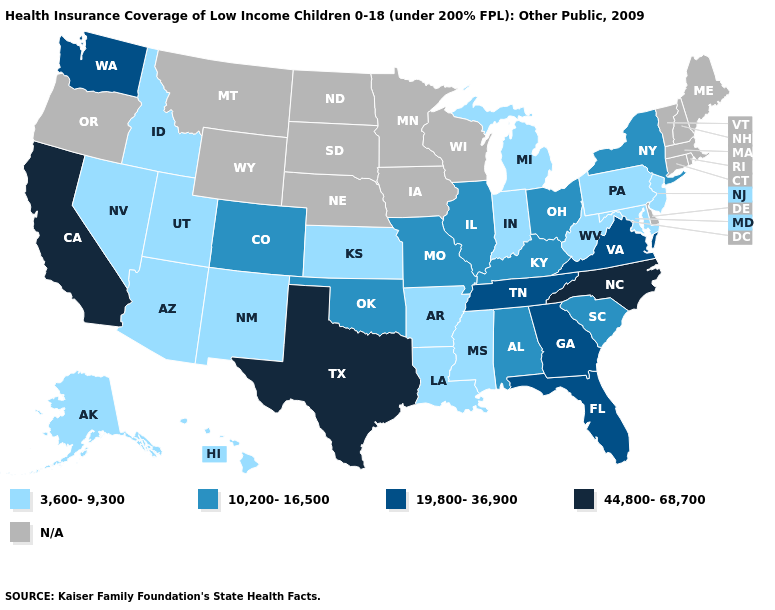What is the value of Missouri?
Answer briefly. 10,200-16,500. What is the lowest value in the USA?
Give a very brief answer. 3,600-9,300. What is the lowest value in the Northeast?
Concise answer only. 3,600-9,300. What is the value of Colorado?
Concise answer only. 10,200-16,500. What is the highest value in the Northeast ?
Give a very brief answer. 10,200-16,500. What is the highest value in the USA?
Answer briefly. 44,800-68,700. What is the lowest value in states that border Oklahoma?
Be succinct. 3,600-9,300. What is the lowest value in the Northeast?
Quick response, please. 3,600-9,300. What is the value of Idaho?
Write a very short answer. 3,600-9,300. What is the value of Mississippi?
Concise answer only. 3,600-9,300. What is the value of Massachusetts?
Be succinct. N/A. Does Texas have the lowest value in the South?
Keep it brief. No. What is the lowest value in states that border California?
Short answer required. 3,600-9,300. Name the states that have a value in the range 10,200-16,500?
Concise answer only. Alabama, Colorado, Illinois, Kentucky, Missouri, New York, Ohio, Oklahoma, South Carolina. 